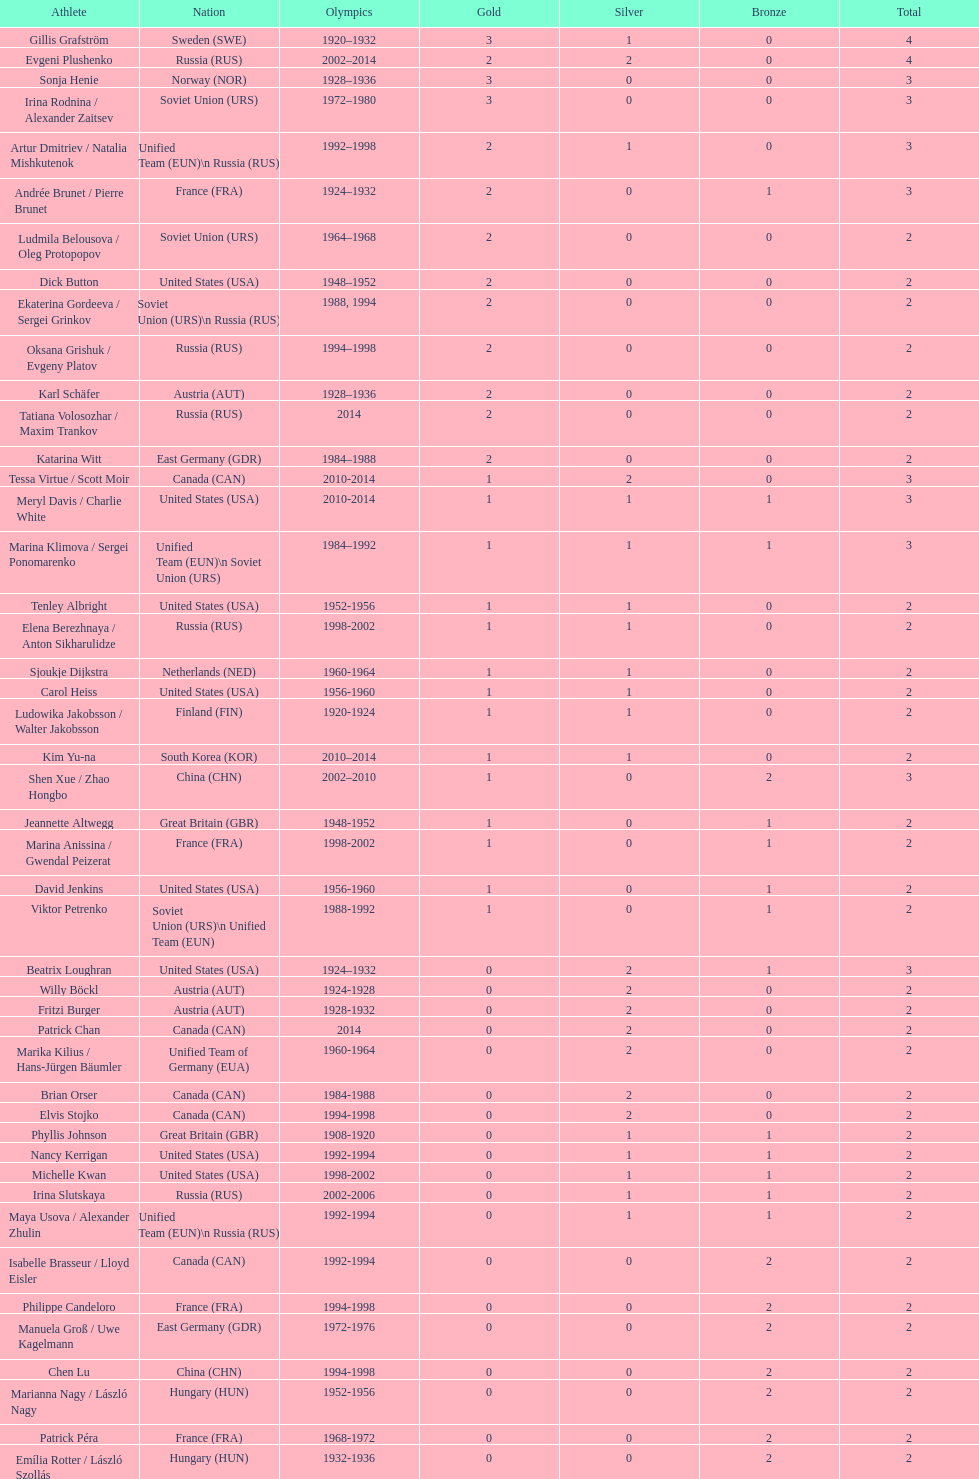Which sportsman hails from south korea post-2010? Kim Yu-na. 